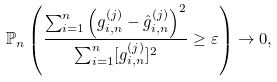Convert formula to latex. <formula><loc_0><loc_0><loc_500><loc_500>\mathbb { P } _ { n } \left ( \frac { \sum _ { i = 1 } ^ { n } \left ( g _ { i , n } ^ { ( j ) } - \hat { g } _ { i , n } ^ { ( j ) } \right ) ^ { 2 } } { \sum _ { i = 1 } ^ { n } [ g _ { i , n } ^ { ( j ) } ] ^ { 2 } } \geq \varepsilon \right ) \to 0 ,</formula> 